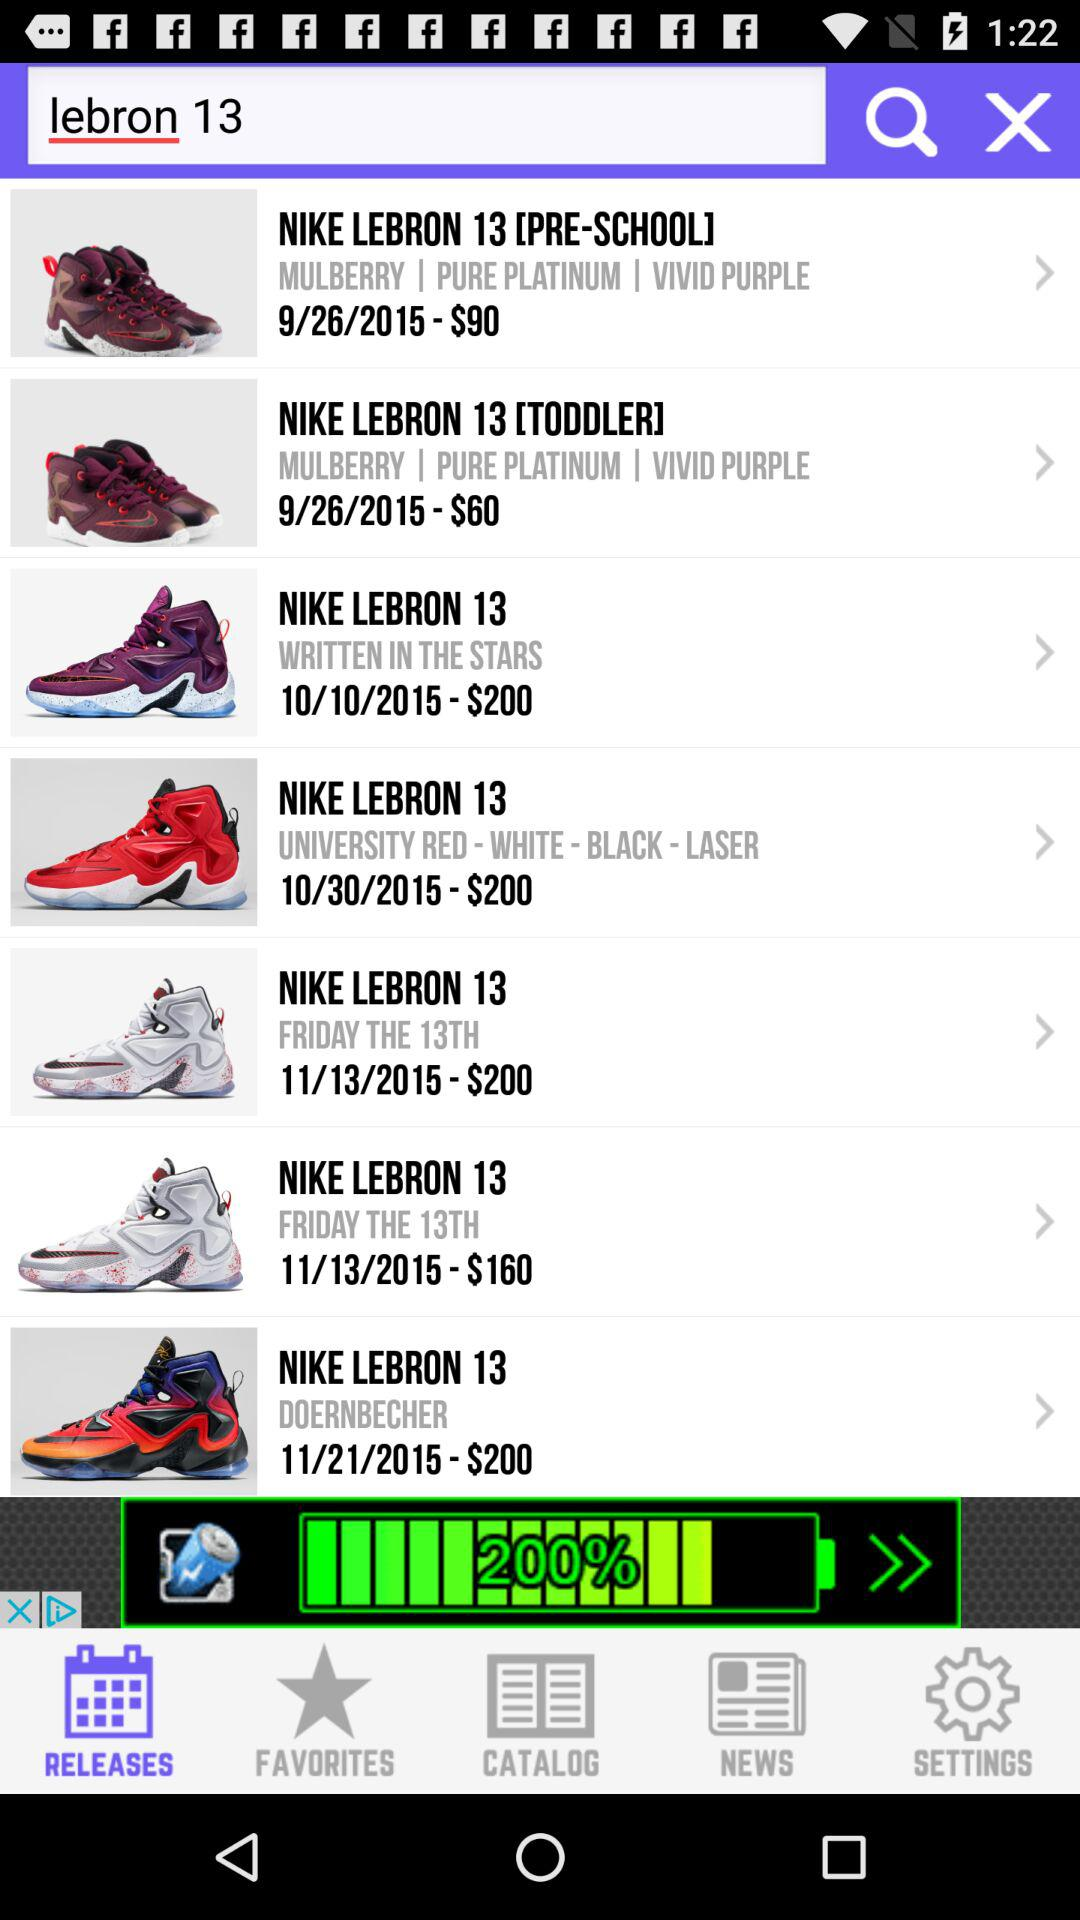What is the price of the "NIKE LEBRON 13 [PRE-SCHOOL]"? The price of the "NIKE LEBRON 13 [PRE-SCHOOL]" is $90. 